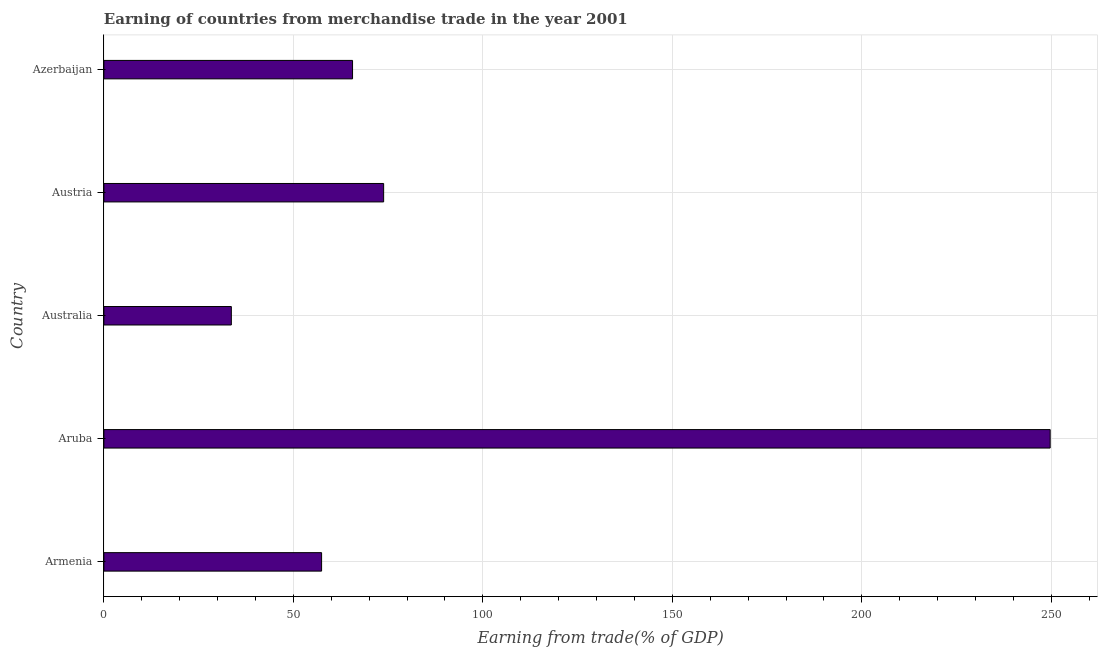Does the graph contain any zero values?
Provide a short and direct response. No. What is the title of the graph?
Provide a short and direct response. Earning of countries from merchandise trade in the year 2001. What is the label or title of the X-axis?
Provide a succinct answer. Earning from trade(% of GDP). What is the label or title of the Y-axis?
Your answer should be compact. Country. What is the earning from merchandise trade in Aruba?
Keep it short and to the point. 249.7. Across all countries, what is the maximum earning from merchandise trade?
Offer a terse response. 249.7. Across all countries, what is the minimum earning from merchandise trade?
Make the answer very short. 33.63. In which country was the earning from merchandise trade maximum?
Ensure brevity in your answer.  Aruba. In which country was the earning from merchandise trade minimum?
Give a very brief answer. Australia. What is the sum of the earning from merchandise trade?
Ensure brevity in your answer.  480.21. What is the difference between the earning from merchandise trade in Armenia and Aruba?
Keep it short and to the point. -192.25. What is the average earning from merchandise trade per country?
Your response must be concise. 96.04. What is the median earning from merchandise trade?
Your answer should be compact. 65.61. In how many countries, is the earning from merchandise trade greater than 120 %?
Make the answer very short. 1. What is the ratio of the earning from merchandise trade in Aruba to that in Austria?
Your response must be concise. 3.38. What is the difference between the highest and the second highest earning from merchandise trade?
Your response must be concise. 175.88. What is the difference between the highest and the lowest earning from merchandise trade?
Provide a short and direct response. 216.07. Are all the bars in the graph horizontal?
Keep it short and to the point. Yes. What is the Earning from trade(% of GDP) of Armenia?
Provide a short and direct response. 57.45. What is the Earning from trade(% of GDP) of Aruba?
Make the answer very short. 249.7. What is the Earning from trade(% of GDP) in Australia?
Your answer should be compact. 33.63. What is the Earning from trade(% of GDP) in Austria?
Make the answer very short. 73.82. What is the Earning from trade(% of GDP) in Azerbaijan?
Offer a very short reply. 65.61. What is the difference between the Earning from trade(% of GDP) in Armenia and Aruba?
Give a very brief answer. -192.25. What is the difference between the Earning from trade(% of GDP) in Armenia and Australia?
Offer a very short reply. 23.82. What is the difference between the Earning from trade(% of GDP) in Armenia and Austria?
Your answer should be compact. -16.37. What is the difference between the Earning from trade(% of GDP) in Armenia and Azerbaijan?
Your answer should be very brief. -8.17. What is the difference between the Earning from trade(% of GDP) in Aruba and Australia?
Give a very brief answer. 216.07. What is the difference between the Earning from trade(% of GDP) in Aruba and Austria?
Provide a succinct answer. 175.88. What is the difference between the Earning from trade(% of GDP) in Aruba and Azerbaijan?
Your answer should be very brief. 184.08. What is the difference between the Earning from trade(% of GDP) in Australia and Austria?
Your response must be concise. -40.19. What is the difference between the Earning from trade(% of GDP) in Australia and Azerbaijan?
Make the answer very short. -31.98. What is the difference between the Earning from trade(% of GDP) in Austria and Azerbaijan?
Provide a short and direct response. 8.2. What is the ratio of the Earning from trade(% of GDP) in Armenia to that in Aruba?
Your response must be concise. 0.23. What is the ratio of the Earning from trade(% of GDP) in Armenia to that in Australia?
Provide a succinct answer. 1.71. What is the ratio of the Earning from trade(% of GDP) in Armenia to that in Austria?
Your answer should be compact. 0.78. What is the ratio of the Earning from trade(% of GDP) in Armenia to that in Azerbaijan?
Your answer should be compact. 0.88. What is the ratio of the Earning from trade(% of GDP) in Aruba to that in Australia?
Your answer should be compact. 7.42. What is the ratio of the Earning from trade(% of GDP) in Aruba to that in Austria?
Give a very brief answer. 3.38. What is the ratio of the Earning from trade(% of GDP) in Aruba to that in Azerbaijan?
Your response must be concise. 3.81. What is the ratio of the Earning from trade(% of GDP) in Australia to that in Austria?
Give a very brief answer. 0.46. What is the ratio of the Earning from trade(% of GDP) in Australia to that in Azerbaijan?
Make the answer very short. 0.51. What is the ratio of the Earning from trade(% of GDP) in Austria to that in Azerbaijan?
Your answer should be compact. 1.12. 